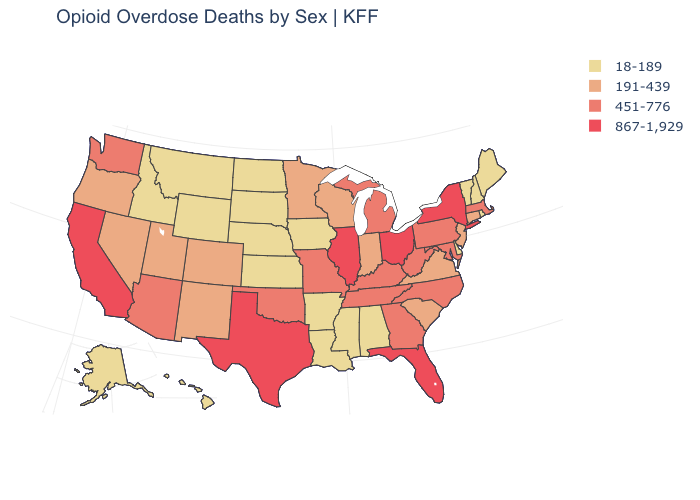Does Ohio have the same value as West Virginia?
Quick response, please. No. Is the legend a continuous bar?
Give a very brief answer. No. Does Louisiana have the lowest value in the USA?
Give a very brief answer. Yes. What is the lowest value in the USA?
Quick response, please. 18-189. Name the states that have a value in the range 451-776?
Quick response, please. Arizona, Georgia, Kentucky, Maryland, Massachusetts, Michigan, Missouri, North Carolina, Oklahoma, Pennsylvania, Tennessee, Washington, West Virginia. Does the first symbol in the legend represent the smallest category?
Give a very brief answer. Yes. Does the map have missing data?
Concise answer only. No. Among the states that border Utah , which have the highest value?
Be succinct. Arizona. Does the map have missing data?
Quick response, please. No. Does Ohio have the same value as Utah?
Quick response, please. No. Among the states that border Arkansas , which have the lowest value?
Concise answer only. Louisiana, Mississippi. Which states hav the highest value in the MidWest?
Be succinct. Illinois, Ohio. Does North Dakota have the lowest value in the USA?
Give a very brief answer. Yes. What is the highest value in states that border South Dakota?
Write a very short answer. 191-439. What is the lowest value in the MidWest?
Concise answer only. 18-189. 